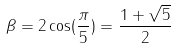<formula> <loc_0><loc_0><loc_500><loc_500>\beta = 2 \cos ( \frac { \pi } { 5 } ) = \frac { 1 + \sqrt { 5 } } { 2 }</formula> 